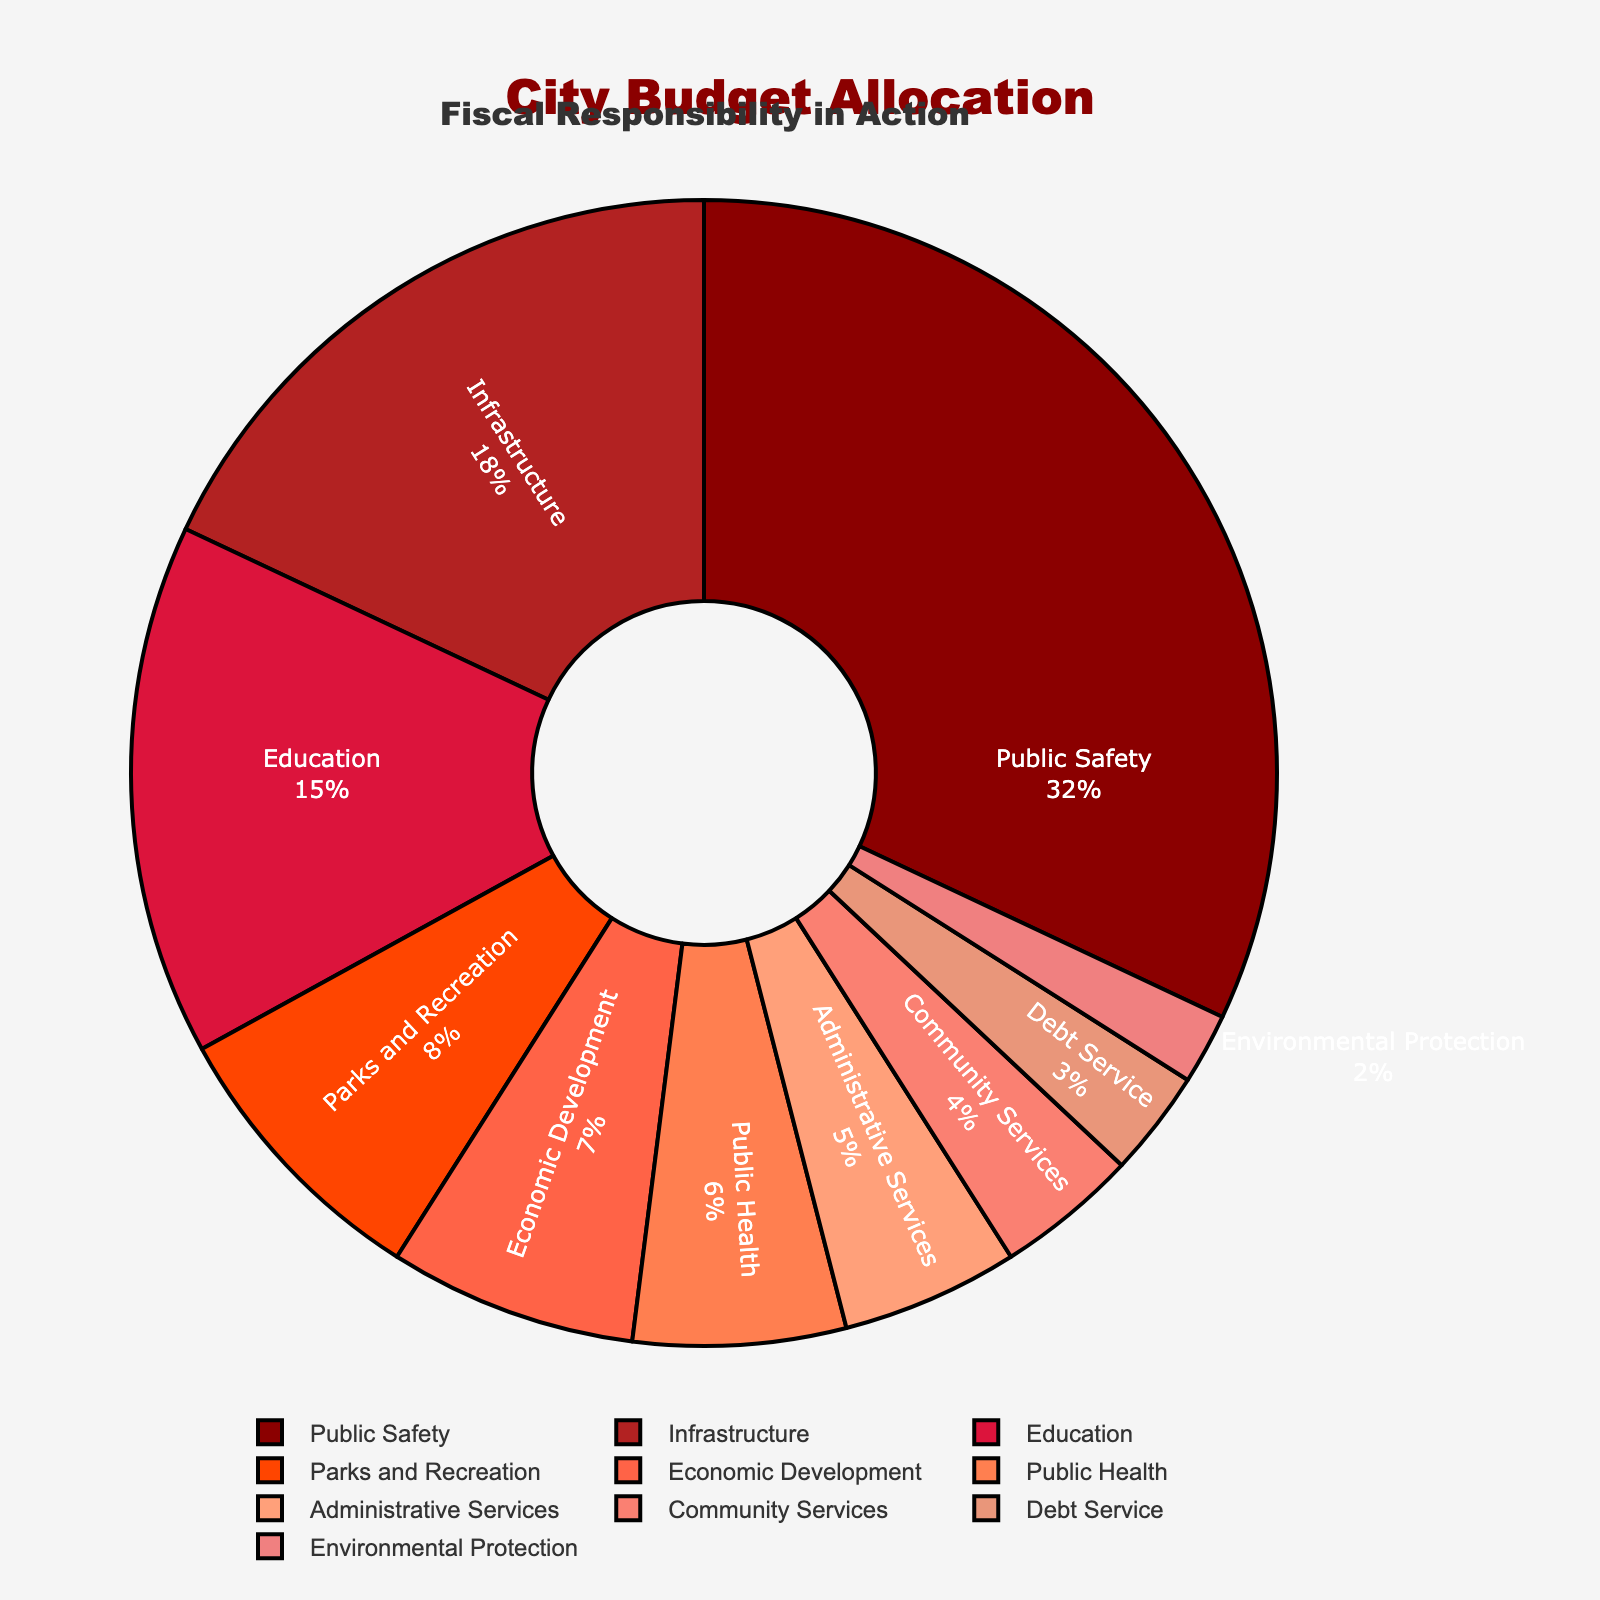Which department has the highest budget allocation? The department with the largest segment in the pie chart and the highest percentage displayed is Public Safety at 32%.
Answer: Public Safety What is the total budget allocation for Infrastructure and Education together? The percentage for Infrastructure is 18% and for Education is 15%. Adding these percentages together: 18 + 15 = 33%.
Answer: 33% Which departments have an equal budget allocation? By observing the pie chart, no two departments have been allocated an equal percentage of the budget as all percentages are different.
Answer: None Is the budget allocation for Public Safety more than double that of Parks and Recreation? Public Safety has a 32% allocation, and Parks and Recreation has an 8% allocation. Double of Parks and Recreation’s allocation is 8 * 2 = 16%, and 32% > 16%.
Answer: Yes What's the difference in budget allocations between Economic Development and Public Health? Economic Development has a budget allocation of 7%, while Public Health has a budget allocation of 6%. The difference is 7 - 6 = 1%.
Answer: 1% Which has a larger budget allocation: Environmental Protection or Debt Service? By comparing the two slices on the pie chart, Debt Service has a larger percentage (3%) compared to Environmental Protection (2%).
Answer: Debt Service Can you list the departments whose budget allocations are less than 10%? By assessing the chart, the departments with less than 10% are Parks and Recreation (8%), Economic Development (7%), Public Health (6%), Administrative Services (5%), Community Services (4%), Debt Service (3%), and Environmental Protection (2%).
Answer: Parks and Recreation, Economic Development, Public Health, Administrative Services, Community Services, Debt Service, Environmental Protection What’s the total percentage of budget allocation for Public Health, Administrative Services, and Community Services? Summing the percentages for these departments: Public Health (6%) + Administrative Services (5%) + Community Services (4%) = 6 + 5 + 4 = 15%.
Answer: 15% What percentage of the budget is allocated to other departments excluding Public Safety, Infrastructure, and Education? By excluding Public Safety (32%), Infrastructure (18%), and Education (15%), we sum the remaining allocations: 100 - 32 - 18 - 15 = 35%.
Answer: 35% What is the ratio of the budget allocation of Public Safety to that of Infrastructure? The budget allocation for Public Safety is 32%, and for Infrastructure, it is 18%. The ratio is calculated as 32 / 18, which simplifies approximately to 1.78.
Answer: 1.78 